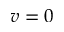<formula> <loc_0><loc_0><loc_500><loc_500>v = 0</formula> 